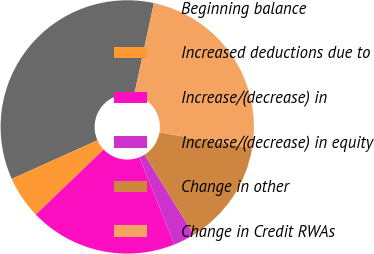<chart> <loc_0><loc_0><loc_500><loc_500><pie_chart><fcel>Beginning balance<fcel>Increased deductions due to<fcel>Increase/(decrease) in<fcel>Increase/(decrease) in equity<fcel>Change in other<fcel>Change in Credit RWAs<nl><fcel>35.1%<fcel>5.43%<fcel>18.91%<fcel>2.73%<fcel>13.52%<fcel>24.31%<nl></chart> 